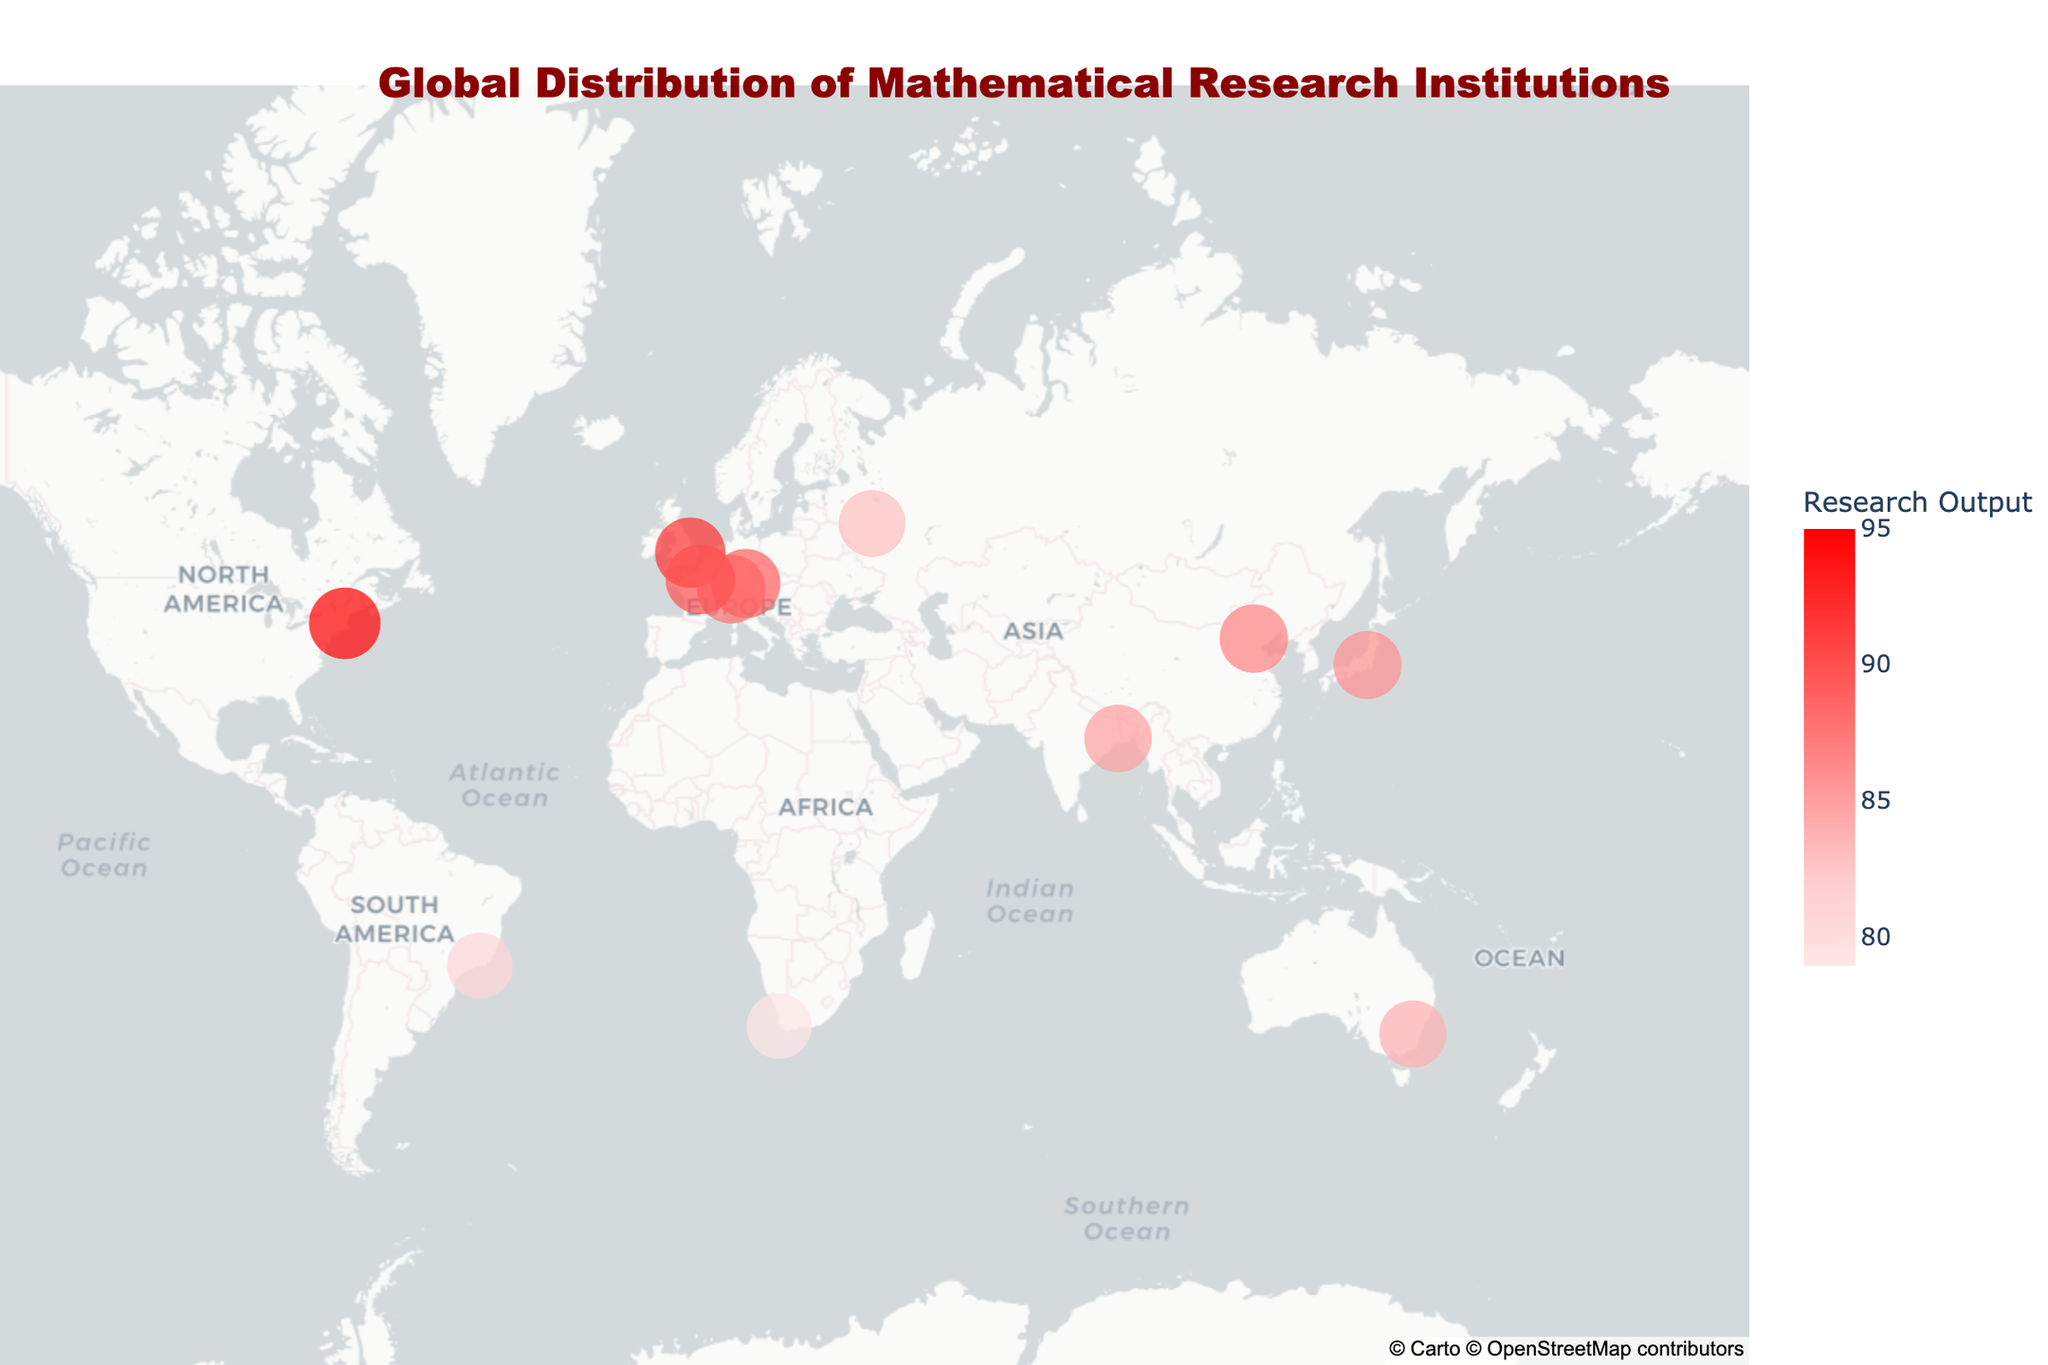What is the title of the figure? The title is usually placed at the top of the figure. In this case, it reads "Global Distribution of Mathematical Research Institutions".
Answer: Global Distribution of Mathematical Research Institutions Which institution has the highest research output? By looking at the sizes and colors of the points, you can identify that Harvard University has the highest research output of 95, as indicated by the largest and darkest red point.
Answer: Harvard University What specialization does the University of Tokyo focus on? Hover over the point representing the University of Tokyo (in Japan), you can see the specialization mentioned in the hover data as "Topology".
Answer: Topology How many institutions are located in Europe? Identify the points located in Europe and count them. These points are in the UK, Switzerland, Germany, France, and Russia, making a total of 5 institutions.
Answer: 5 Which country has the institution focusing on Financial Mathematics? Hover over the point located in South Africa, as indicated by its location on the map. The hover data will show that the University of Cape Town specializes in Financial Mathematics.
Answer: South Africa What is the average research output of institutions in Asia? Look at the institutions in Asia (China, Japan, India, and Russia), and calculate their average research outputs: (87 + 86 + 85 + 83) / 4 = 85.25.
Answer: 85.25 Is there any institution in the Southern Hemisphere? If so, name them. Check the points below the equator. You will find two points: IMPA in Brazil and the Australian National University in Australia.
Answer: Yes, IMPA and Australian National University Which institution specializes in Algebraic Geometry? Hover over the institution located in the UK. The hover text will reveal that the University of Cambridge specializes in Algebraic Geometry.
Answer: University of Cambridge Compare the research output of institutions in the USA and Germany. Which one is higher? Identify the points in the USA and Germany on the map, then compare their research output values. Harvard University in the USA has a research output of 95, while the Max Planck Institute in Germany has a research output of 89.
Answer: USA What is the sum total of research outputs for institutions in the Americas? Identify institutions located in the Americas (USA and Brazil), and sum their research outputs: 95 (Harvard University) + 81 (IMPA) = 176.
Answer: 176 